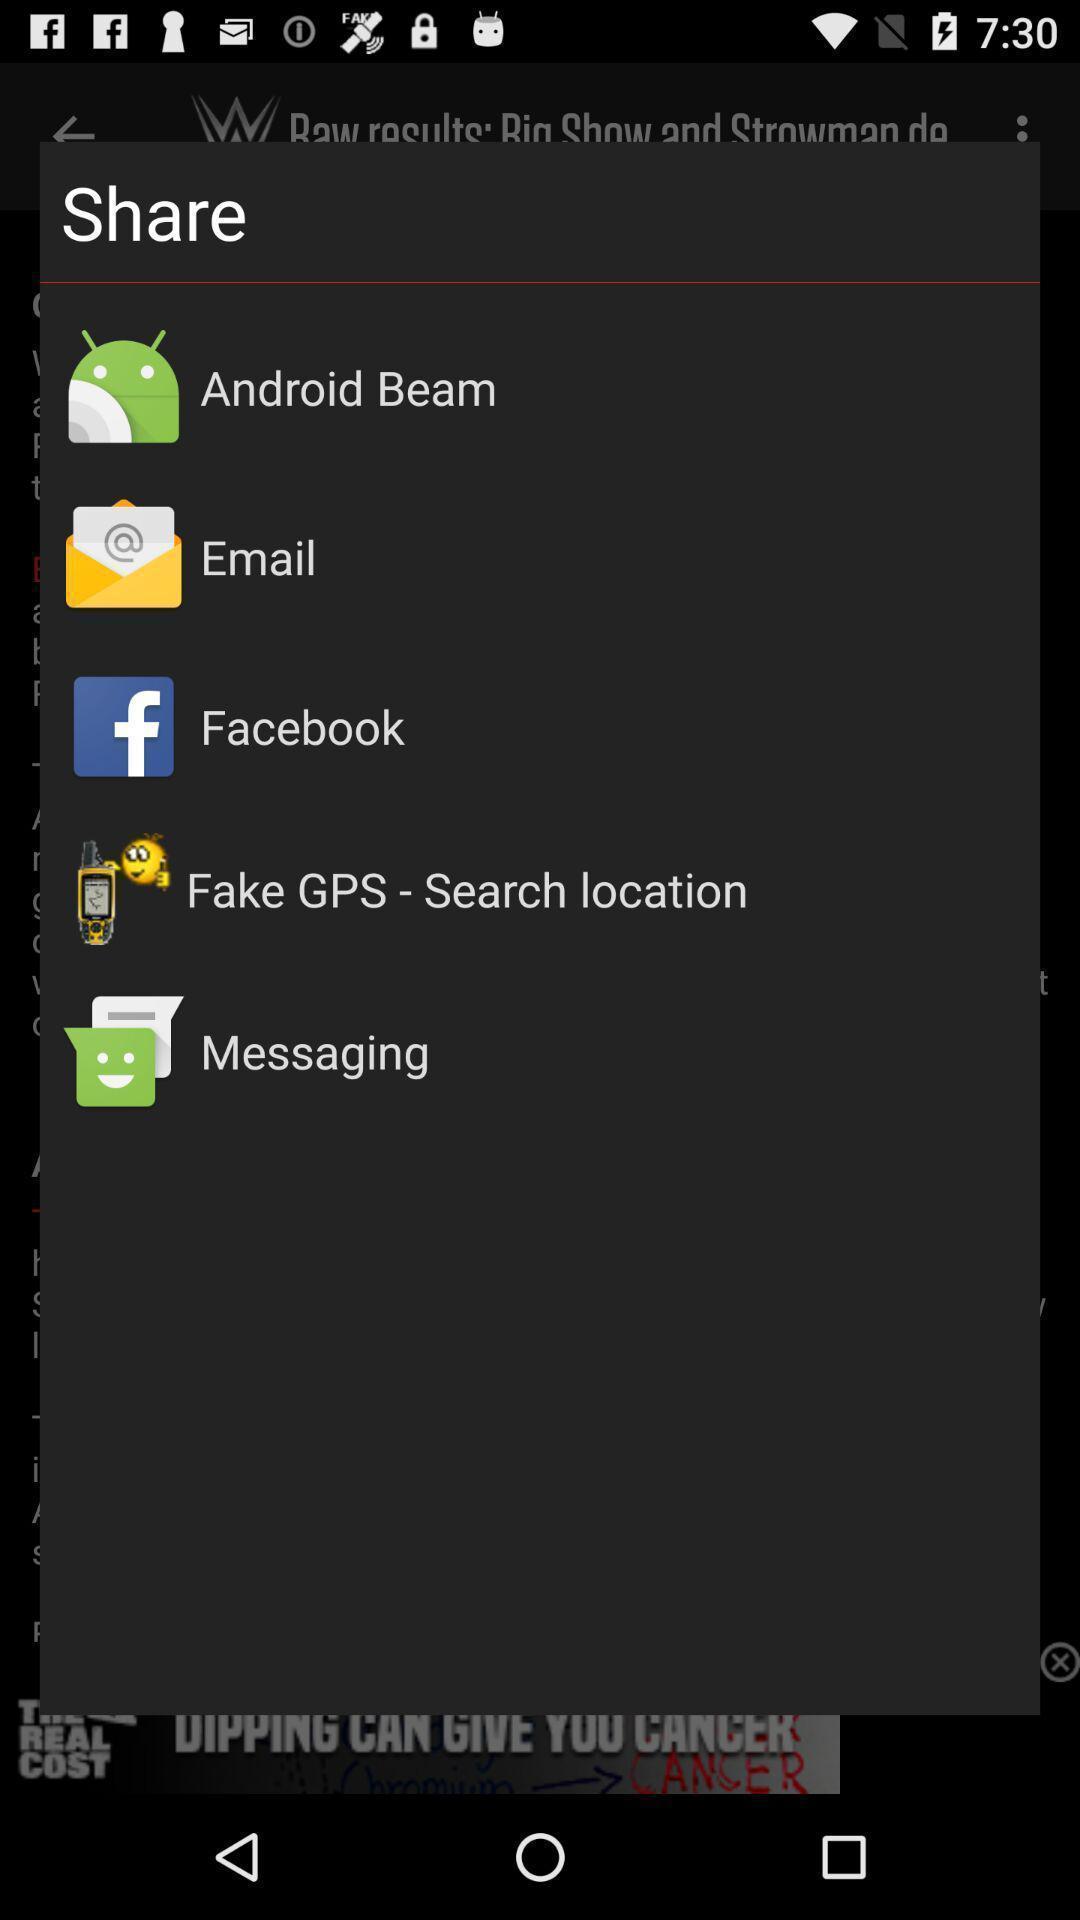What is the overall content of this screenshot? Pop-up to share using different apps. 